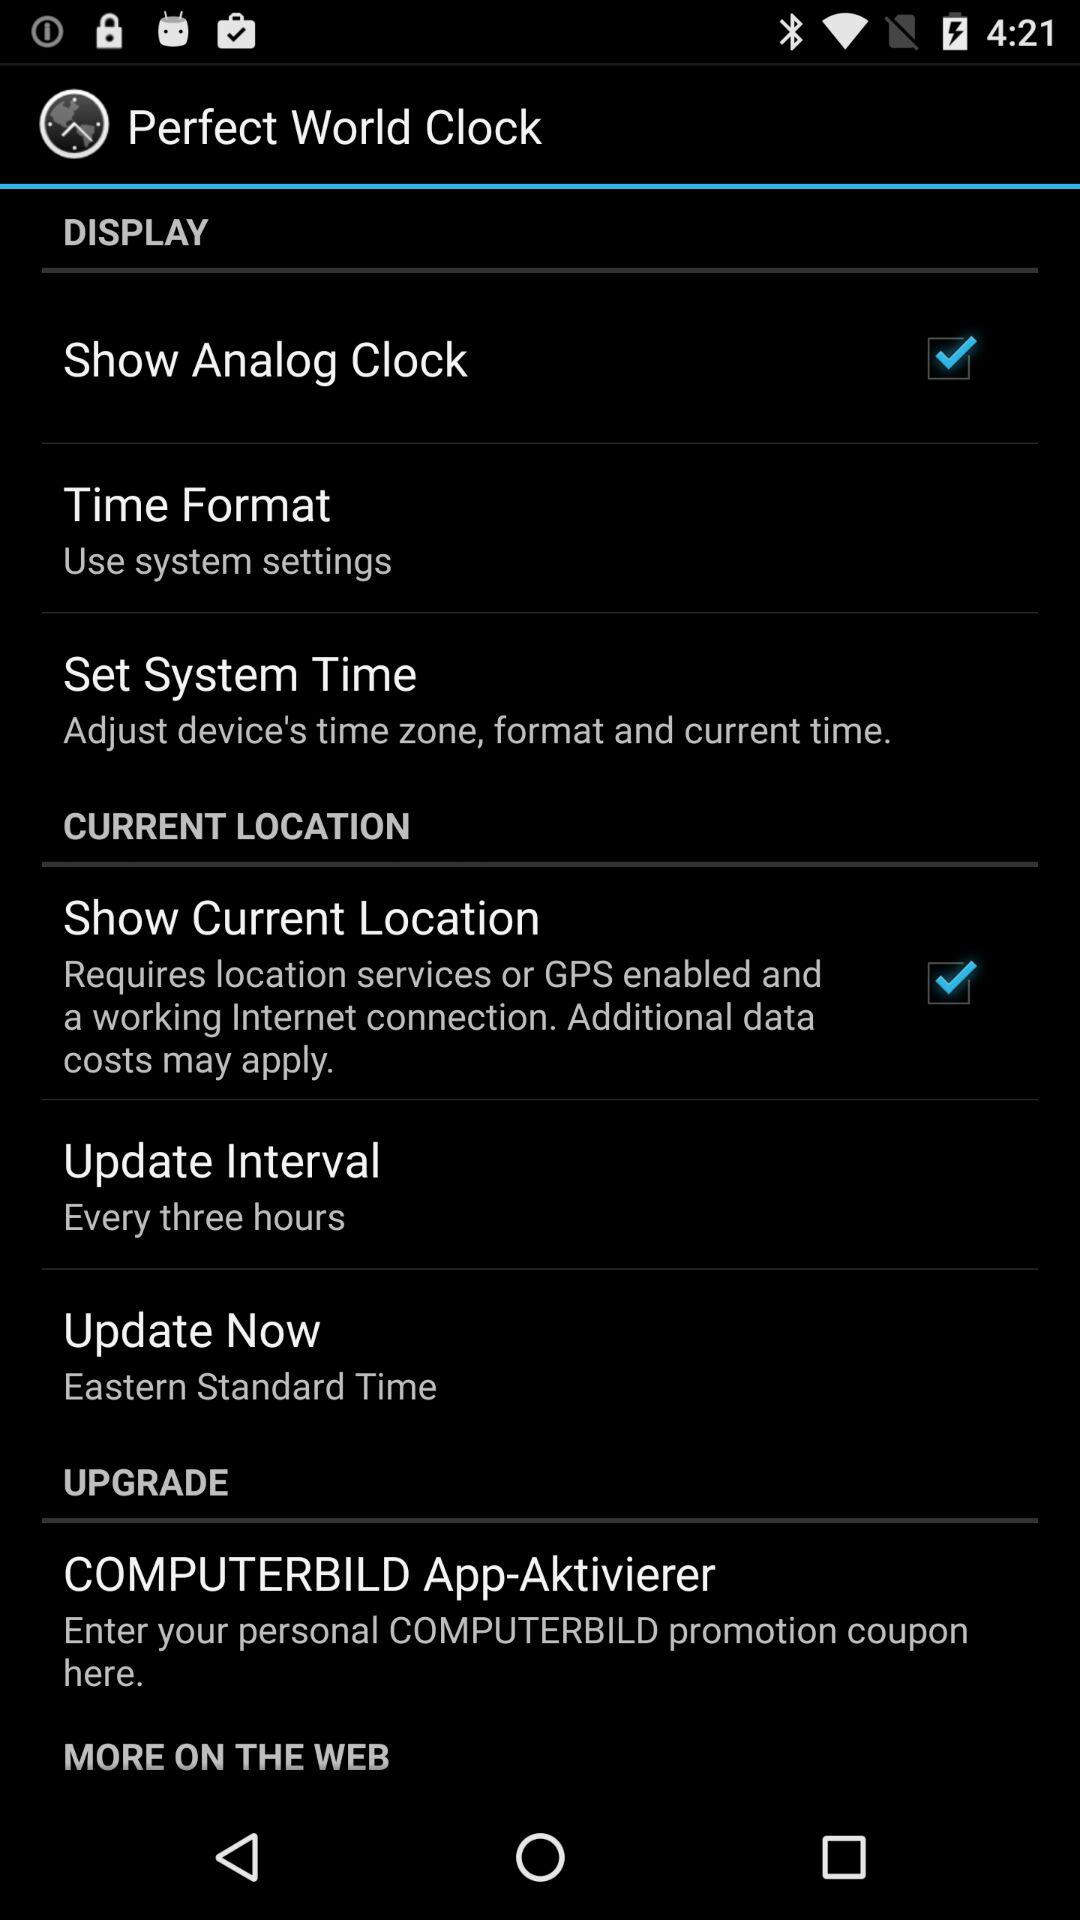What is the time interval between updates? The time interval between updates is three hours. 